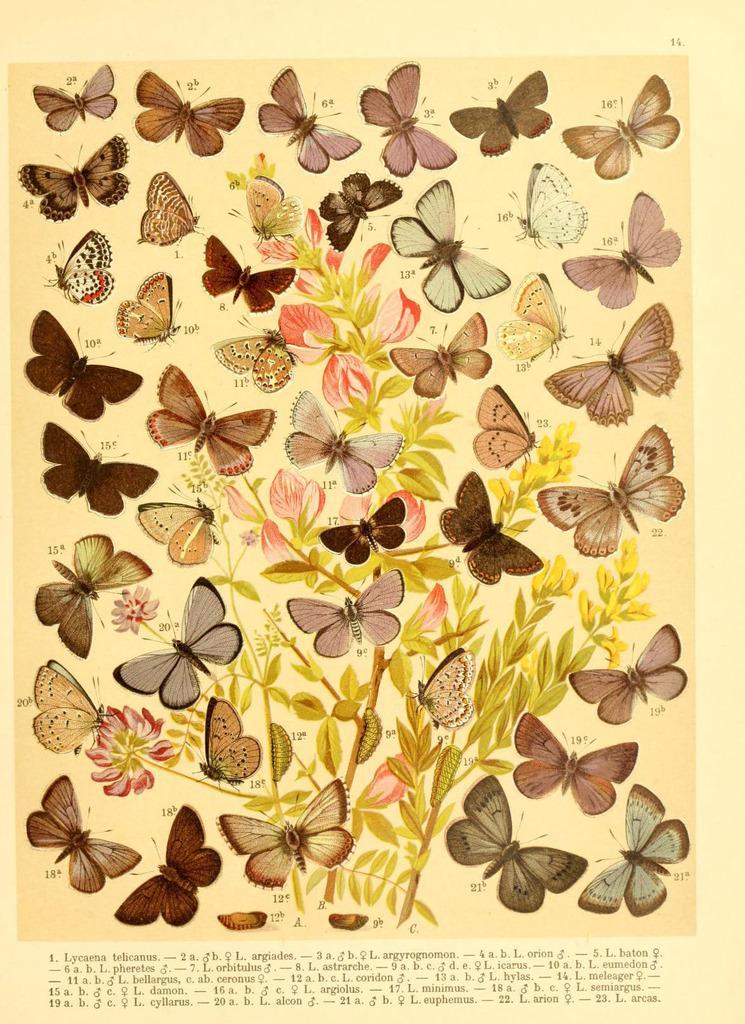How would you summarize this image in a sentence or two? In the image we can see a paper. In the paper we can see a plant and butterflies drawing. 